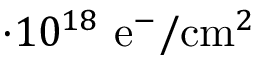<formula> <loc_0><loc_0><loc_500><loc_500>\cdot 1 0 ^ { 1 8 } e ^ { - } / c m ^ { 2 }</formula> 